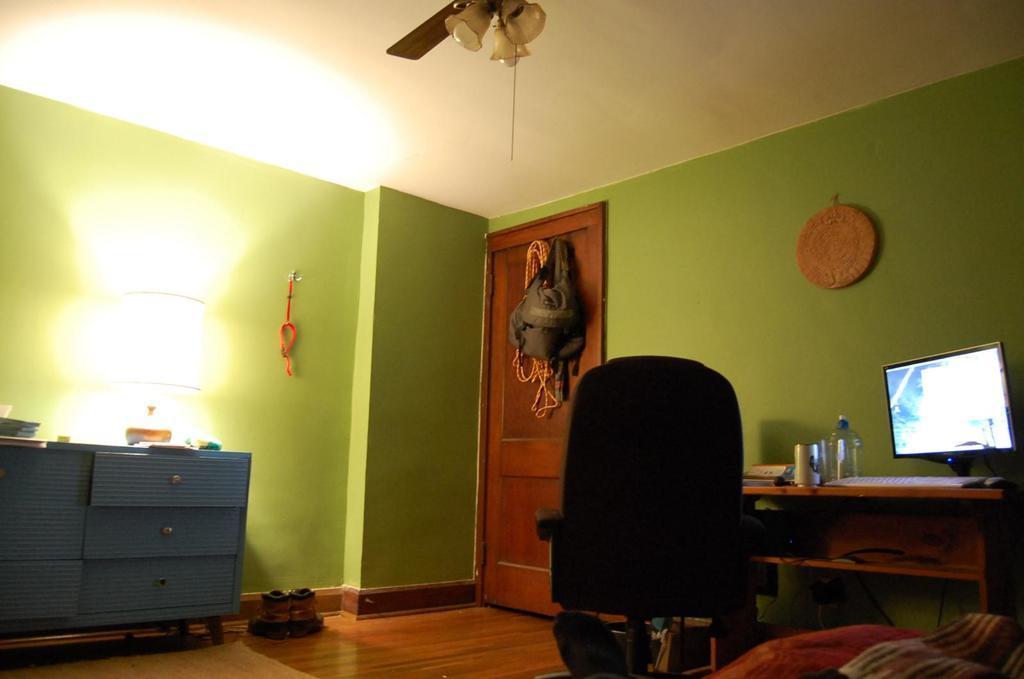Describe this image in one or two sentences. As we can see in the image there is a green color wall, door, fan, white color roof, table and chair. On table there is a screen, keyboard, tin and bottle. On floor there is a shoe. 